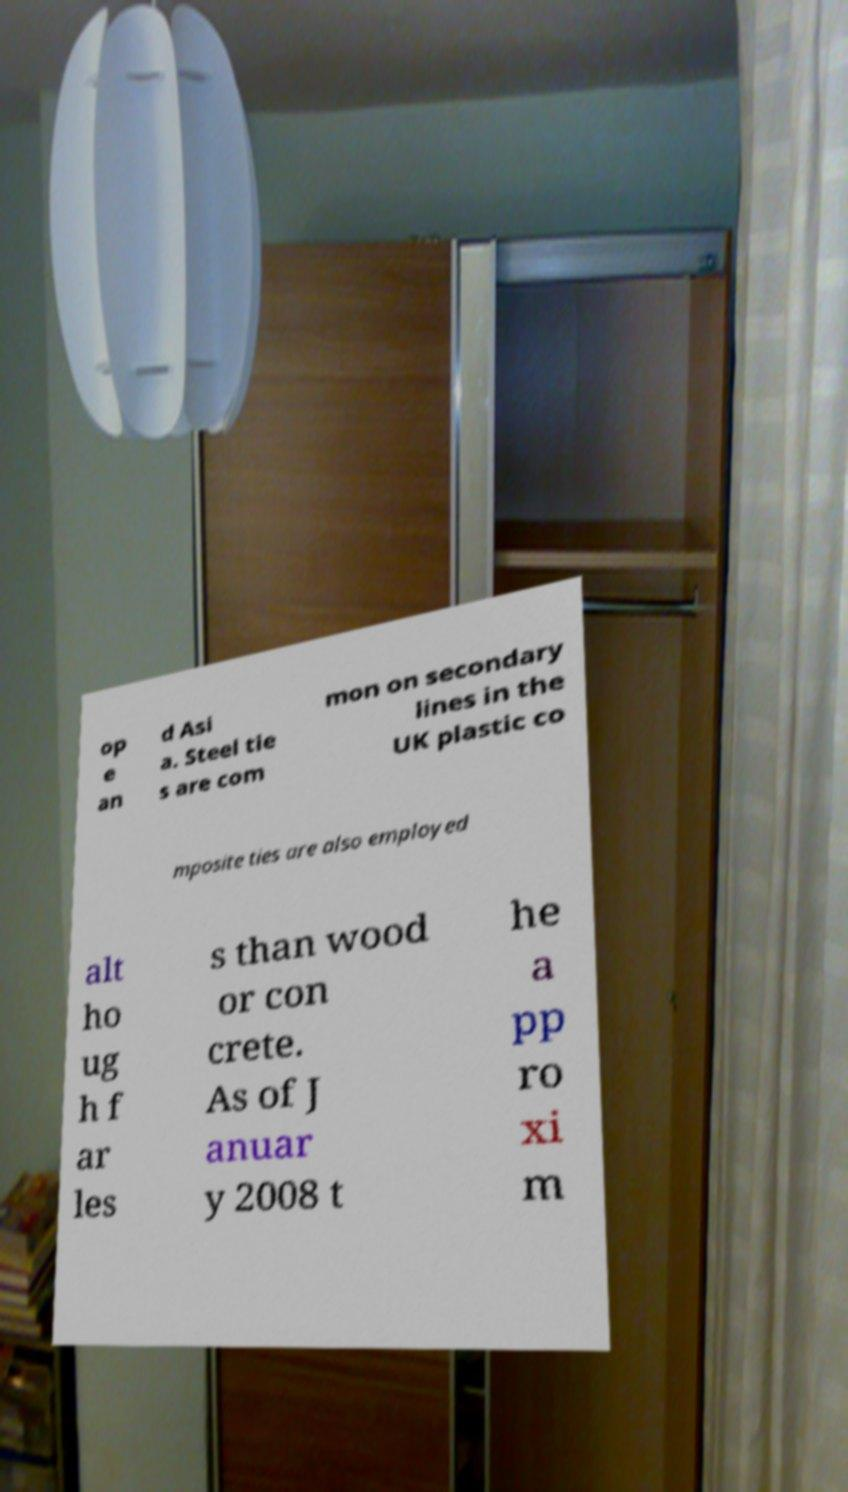What messages or text are displayed in this image? I need them in a readable, typed format. op e an d Asi a. Steel tie s are com mon on secondary lines in the UK plastic co mposite ties are also employed alt ho ug h f ar les s than wood or con crete. As of J anuar y 2008 t he a pp ro xi m 